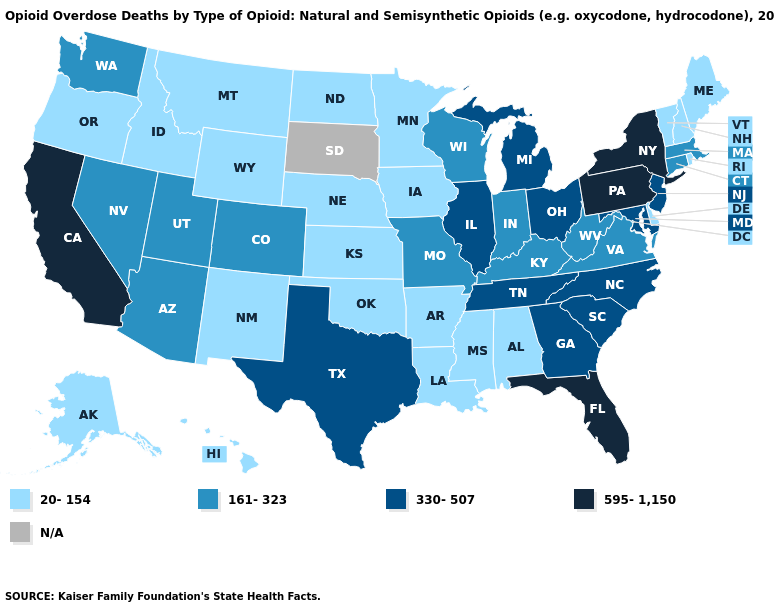What is the lowest value in the USA?
Keep it brief. 20-154. What is the value of Rhode Island?
Be succinct. 20-154. Name the states that have a value in the range 595-1,150?
Give a very brief answer. California, Florida, New York, Pennsylvania. What is the highest value in the South ?
Be succinct. 595-1,150. Which states hav the highest value in the West?
Answer briefly. California. What is the lowest value in the USA?
Write a very short answer. 20-154. Which states have the lowest value in the Northeast?
Give a very brief answer. Maine, New Hampshire, Rhode Island, Vermont. Does North Carolina have the lowest value in the USA?
Be succinct. No. What is the value of Kentucky?
Answer briefly. 161-323. How many symbols are there in the legend?
Be succinct. 5. Name the states that have a value in the range 161-323?
Give a very brief answer. Arizona, Colorado, Connecticut, Indiana, Kentucky, Massachusetts, Missouri, Nevada, Utah, Virginia, Washington, West Virginia, Wisconsin. What is the value of North Carolina?
Give a very brief answer. 330-507. Among the states that border Delaware , which have the lowest value?
Keep it brief. Maryland, New Jersey. 